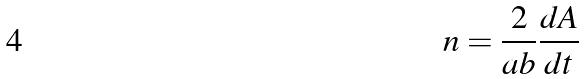<formula> <loc_0><loc_0><loc_500><loc_500>n = \frac { 2 } { a b } \frac { d A } { d t }</formula> 